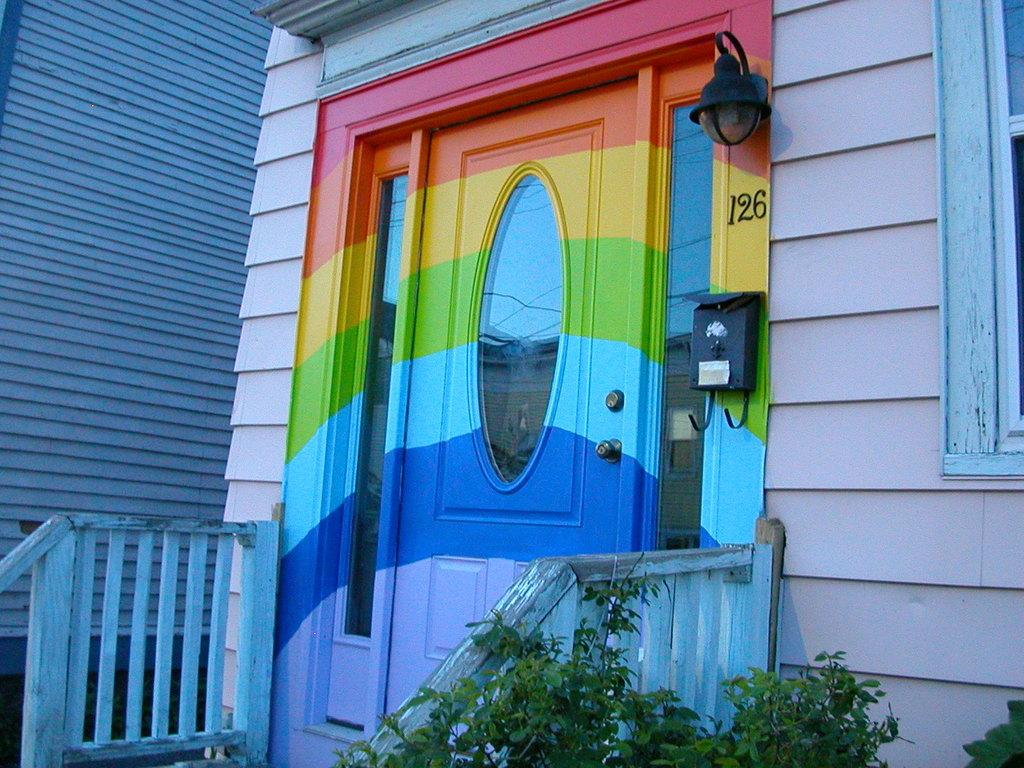What is the main architectural feature in the image? There is a door in the image in the image. What is located in front of the door? There are two railings in front of the door. What other feature can be seen on the side of the image? There is a window on the right side of the image. How many passengers are visible on the ship in the image? There is no ship present in the image, so it is not possible to determine the number of passengers. 